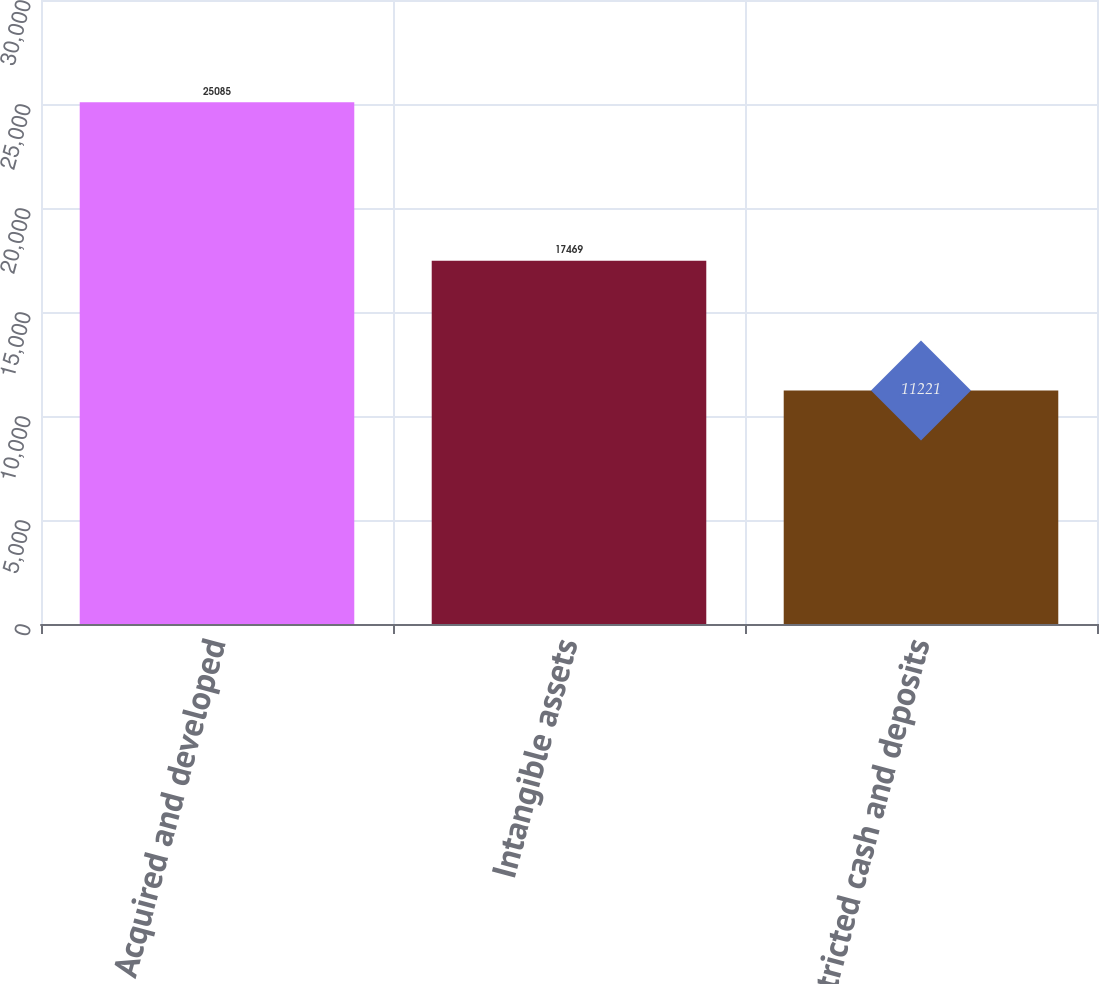Convert chart to OTSL. <chart><loc_0><loc_0><loc_500><loc_500><bar_chart><fcel>Acquired and developed<fcel>Intangible assets<fcel>Restricted cash and deposits<nl><fcel>25085<fcel>17469<fcel>11221<nl></chart> 